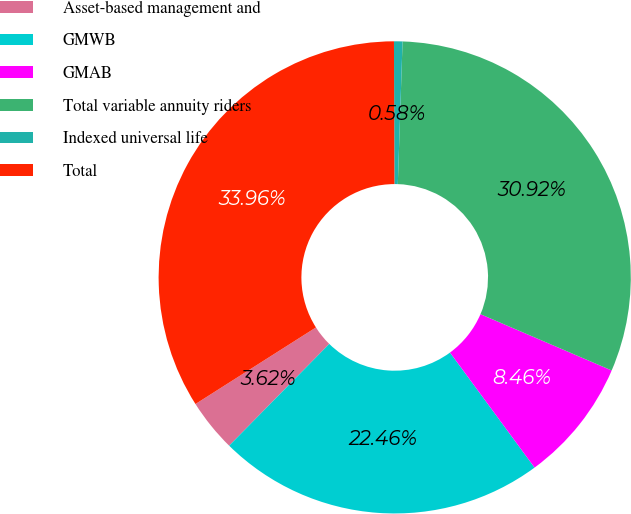<chart> <loc_0><loc_0><loc_500><loc_500><pie_chart><fcel>Asset-based management and<fcel>GMWB<fcel>GMAB<fcel>Total variable annuity riders<fcel>Indexed universal life<fcel>Total<nl><fcel>3.62%<fcel>22.46%<fcel>8.46%<fcel>30.92%<fcel>0.58%<fcel>33.96%<nl></chart> 